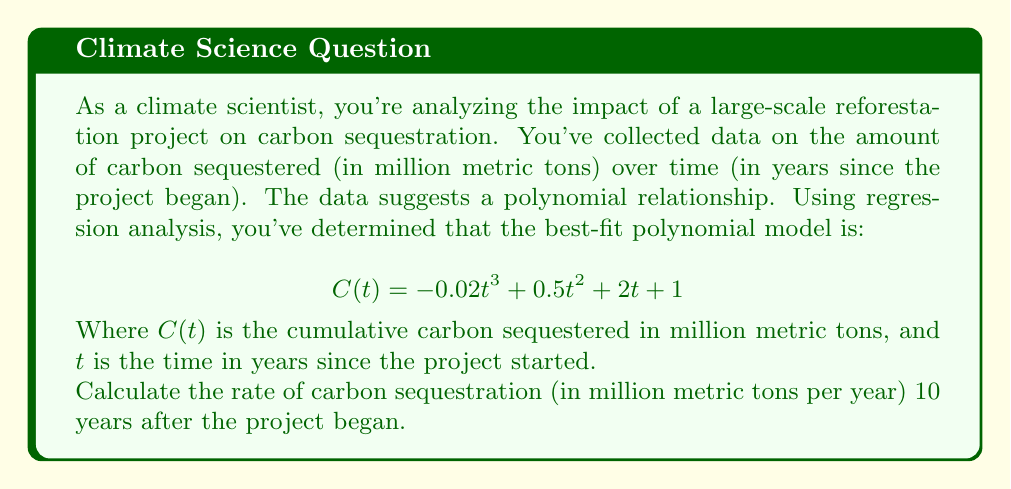What is the answer to this math problem? To solve this problem, we need to follow these steps:

1) The given function $C(t)$ represents the cumulative carbon sequestered over time. To find the rate of carbon sequestration at a specific time, we need to find the derivative of this function.

2) Let's differentiate $C(t)$ with respect to $t$:

   $$ C(t) = -0.02t^3 + 0.5t^2 + 2t + 1 $$
   $$ C'(t) = -0.06t^2 + t + 2 $$

3) The derivative $C'(t)$ represents the rate of change of carbon sequestration at any given time $t$.

4) We need to find the rate at $t = 10$ years. Let's substitute this value:

   $$ C'(10) = -0.06(10)^2 + 10 + 2 $$
   $$ = -0.06(100) + 10 + 2 $$
   $$ = -6 + 10 + 2 $$
   $$ = 6 $$

5) Therefore, the rate of carbon sequestration 10 years after the project began is 6 million metric tons per year.
Answer: 6 million metric tons per year 